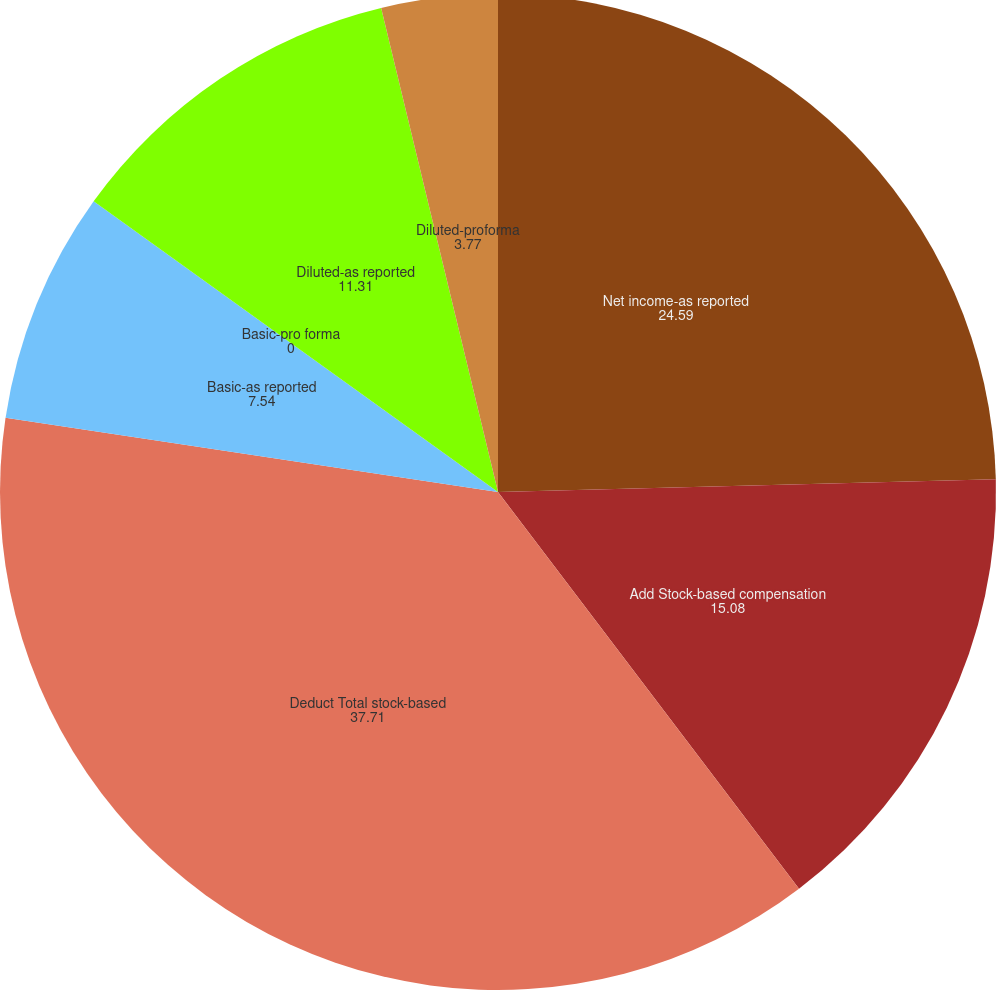<chart> <loc_0><loc_0><loc_500><loc_500><pie_chart><fcel>Net income-as reported<fcel>Add Stock-based compensation<fcel>Deduct Total stock-based<fcel>Basic-as reported<fcel>Basic-pro forma<fcel>Diluted-as reported<fcel>Diluted-proforma<nl><fcel>24.59%<fcel>15.08%<fcel>37.71%<fcel>7.54%<fcel>0.0%<fcel>11.31%<fcel>3.77%<nl></chart> 